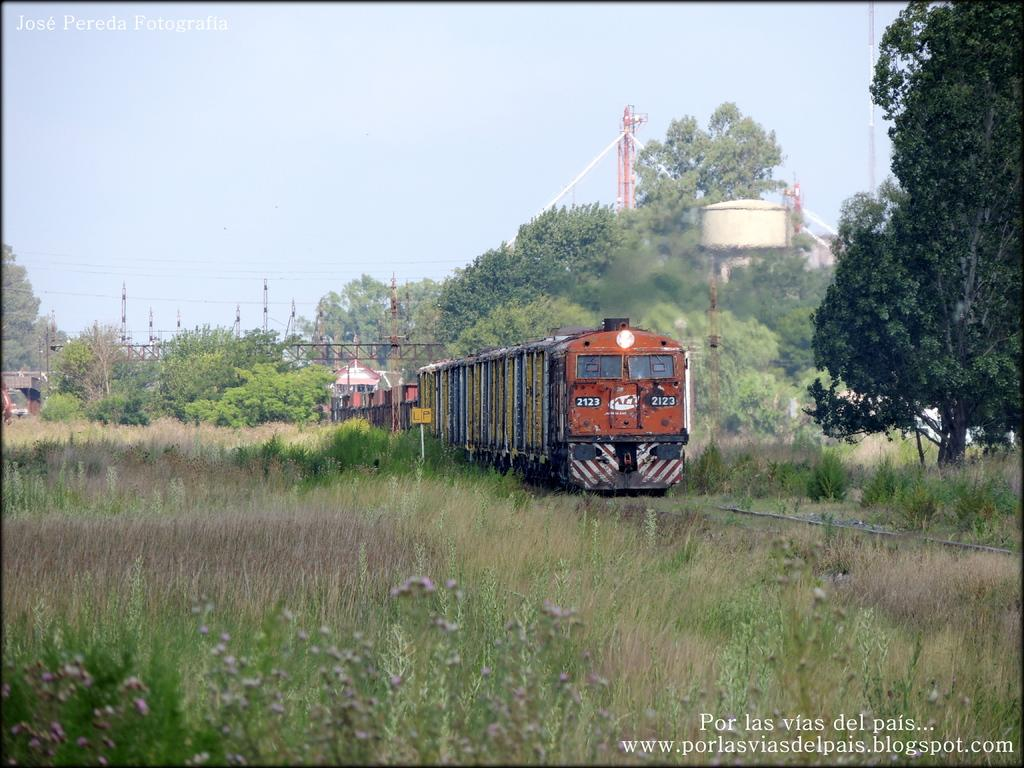<image>
Give a short and clear explanation of the subsequent image. A train with the number 2123 heading down an overgrown track 